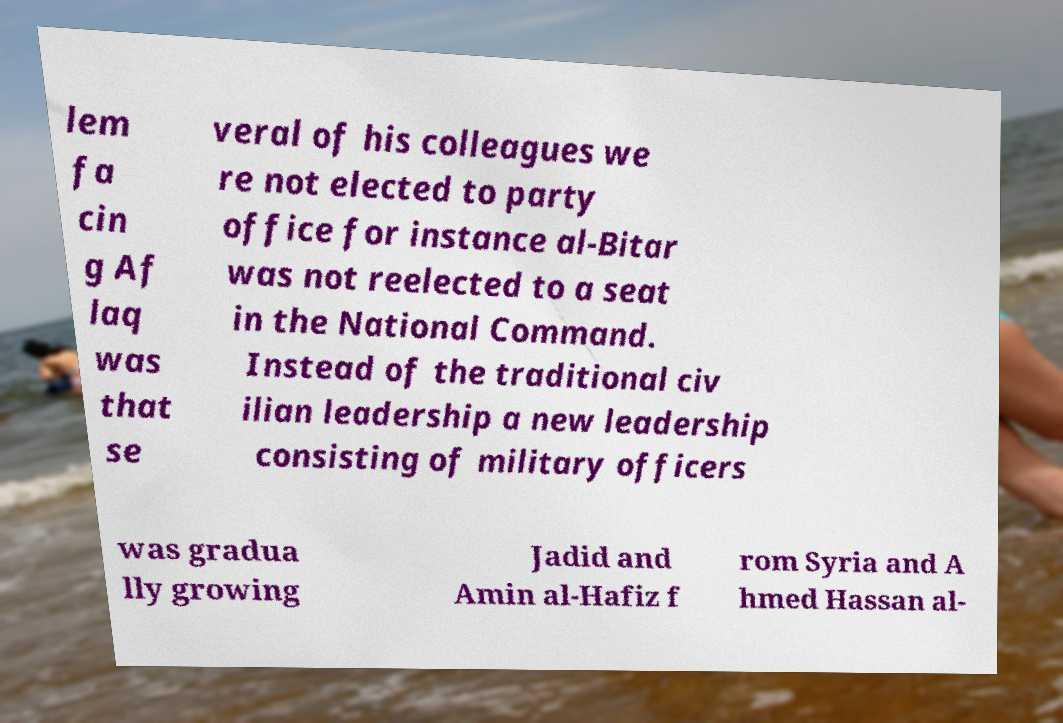For documentation purposes, I need the text within this image transcribed. Could you provide that? lem fa cin g Af laq was that se veral of his colleagues we re not elected to party office for instance al-Bitar was not reelected to a seat in the National Command. Instead of the traditional civ ilian leadership a new leadership consisting of military officers was gradua lly growing Jadid and Amin al-Hafiz f rom Syria and A hmed Hassan al- 